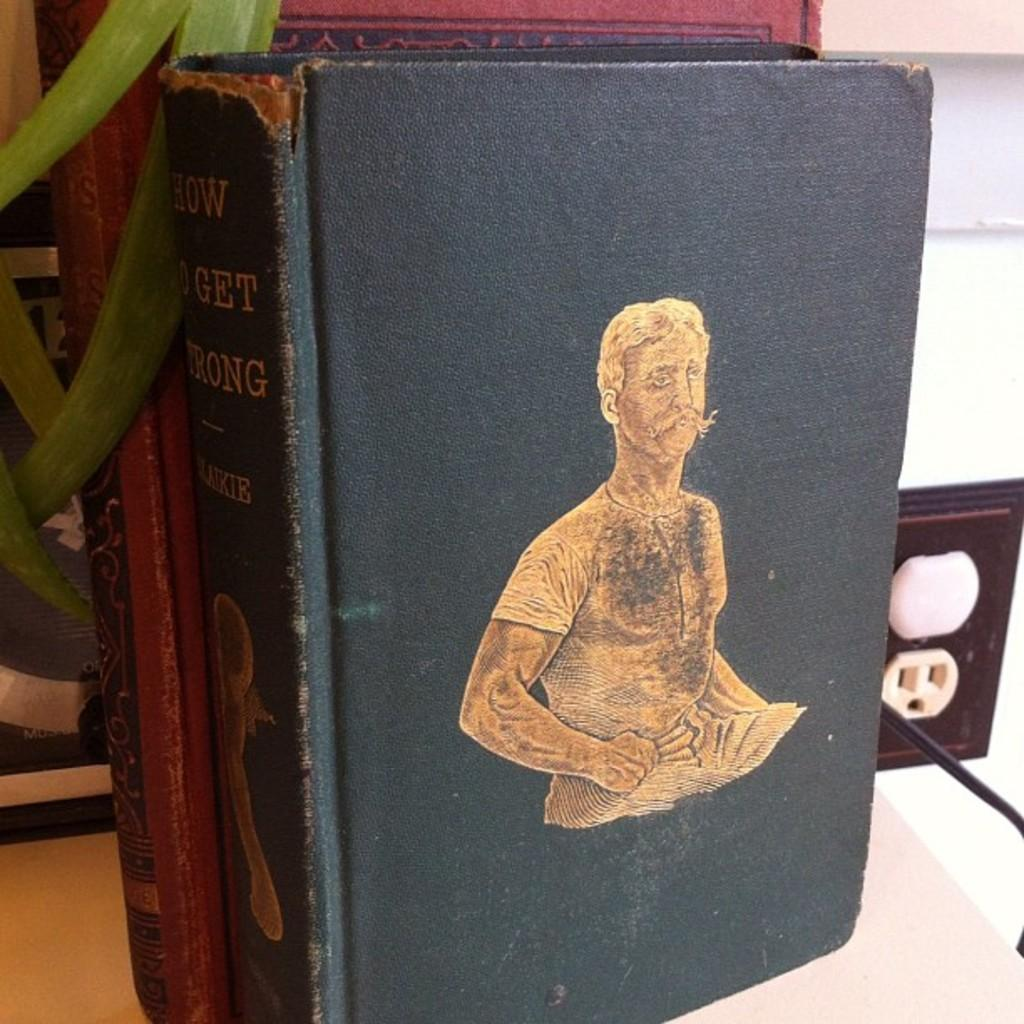Provide a one-sentence caption for the provided image. An old, worn book titled How To Get Wrong. 